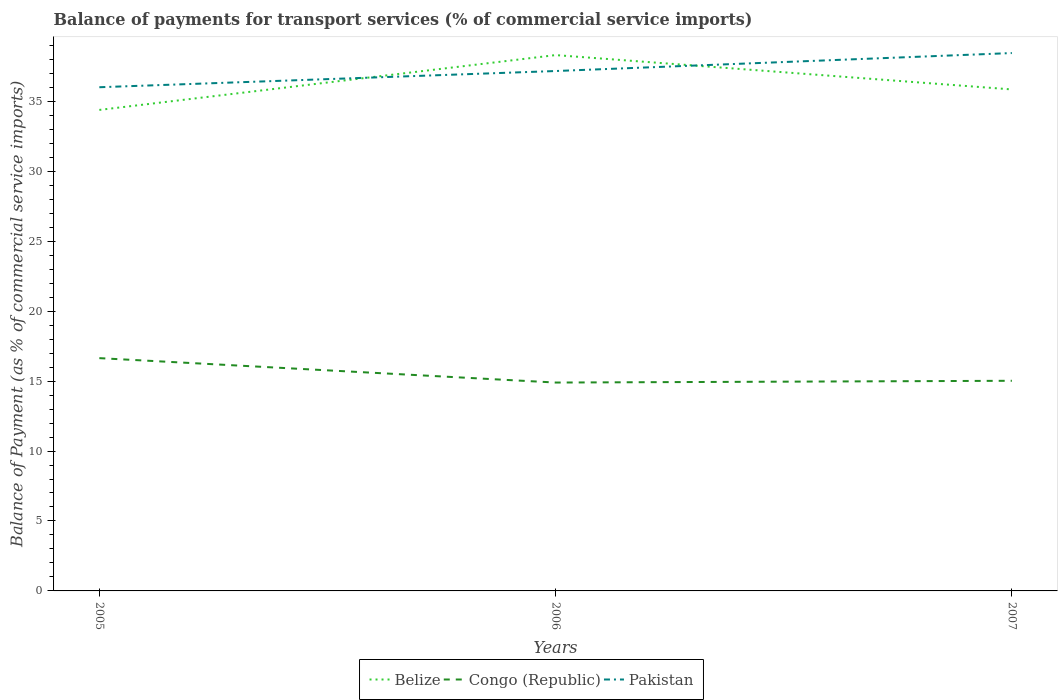Is the number of lines equal to the number of legend labels?
Provide a short and direct response. Yes. Across all years, what is the maximum balance of payments for transport services in Congo (Republic)?
Your answer should be compact. 14.89. In which year was the balance of payments for transport services in Pakistan maximum?
Give a very brief answer. 2005. What is the total balance of payments for transport services in Belize in the graph?
Provide a short and direct response. 2.46. What is the difference between the highest and the second highest balance of payments for transport services in Pakistan?
Your answer should be compact. 2.44. What is the difference between the highest and the lowest balance of payments for transport services in Belize?
Make the answer very short. 1. How many lines are there?
Your answer should be very brief. 3. How many years are there in the graph?
Offer a terse response. 3. What is the difference between two consecutive major ticks on the Y-axis?
Provide a succinct answer. 5. Are the values on the major ticks of Y-axis written in scientific E-notation?
Your answer should be compact. No. Does the graph contain any zero values?
Provide a succinct answer. No. Where does the legend appear in the graph?
Offer a terse response. Bottom center. What is the title of the graph?
Give a very brief answer. Balance of payments for transport services (% of commercial service imports). What is the label or title of the Y-axis?
Make the answer very short. Balance of Payment (as % of commercial service imports). What is the Balance of Payment (as % of commercial service imports) of Belize in 2005?
Ensure brevity in your answer.  34.38. What is the Balance of Payment (as % of commercial service imports) of Congo (Republic) in 2005?
Your answer should be very brief. 16.64. What is the Balance of Payment (as % of commercial service imports) in Pakistan in 2005?
Your answer should be compact. 36. What is the Balance of Payment (as % of commercial service imports) of Belize in 2006?
Keep it short and to the point. 38.3. What is the Balance of Payment (as % of commercial service imports) of Congo (Republic) in 2006?
Provide a short and direct response. 14.89. What is the Balance of Payment (as % of commercial service imports) of Pakistan in 2006?
Offer a terse response. 37.16. What is the Balance of Payment (as % of commercial service imports) of Belize in 2007?
Make the answer very short. 35.85. What is the Balance of Payment (as % of commercial service imports) of Congo (Republic) in 2007?
Offer a very short reply. 15.02. What is the Balance of Payment (as % of commercial service imports) of Pakistan in 2007?
Make the answer very short. 38.45. Across all years, what is the maximum Balance of Payment (as % of commercial service imports) of Belize?
Your answer should be very brief. 38.3. Across all years, what is the maximum Balance of Payment (as % of commercial service imports) in Congo (Republic)?
Make the answer very short. 16.64. Across all years, what is the maximum Balance of Payment (as % of commercial service imports) of Pakistan?
Your answer should be very brief. 38.45. Across all years, what is the minimum Balance of Payment (as % of commercial service imports) of Belize?
Your response must be concise. 34.38. Across all years, what is the minimum Balance of Payment (as % of commercial service imports) in Congo (Republic)?
Give a very brief answer. 14.89. Across all years, what is the minimum Balance of Payment (as % of commercial service imports) in Pakistan?
Keep it short and to the point. 36. What is the total Balance of Payment (as % of commercial service imports) in Belize in the graph?
Provide a short and direct response. 108.53. What is the total Balance of Payment (as % of commercial service imports) in Congo (Republic) in the graph?
Give a very brief answer. 46.56. What is the total Balance of Payment (as % of commercial service imports) in Pakistan in the graph?
Ensure brevity in your answer.  111.62. What is the difference between the Balance of Payment (as % of commercial service imports) in Belize in 2005 and that in 2006?
Offer a terse response. -3.92. What is the difference between the Balance of Payment (as % of commercial service imports) in Congo (Republic) in 2005 and that in 2006?
Give a very brief answer. 1.74. What is the difference between the Balance of Payment (as % of commercial service imports) in Pakistan in 2005 and that in 2006?
Ensure brevity in your answer.  -1.16. What is the difference between the Balance of Payment (as % of commercial service imports) of Belize in 2005 and that in 2007?
Give a very brief answer. -1.46. What is the difference between the Balance of Payment (as % of commercial service imports) in Congo (Republic) in 2005 and that in 2007?
Offer a terse response. 1.62. What is the difference between the Balance of Payment (as % of commercial service imports) in Pakistan in 2005 and that in 2007?
Give a very brief answer. -2.44. What is the difference between the Balance of Payment (as % of commercial service imports) of Belize in 2006 and that in 2007?
Ensure brevity in your answer.  2.46. What is the difference between the Balance of Payment (as % of commercial service imports) in Congo (Republic) in 2006 and that in 2007?
Your response must be concise. -0.13. What is the difference between the Balance of Payment (as % of commercial service imports) of Pakistan in 2006 and that in 2007?
Offer a terse response. -1.28. What is the difference between the Balance of Payment (as % of commercial service imports) of Belize in 2005 and the Balance of Payment (as % of commercial service imports) of Congo (Republic) in 2006?
Give a very brief answer. 19.49. What is the difference between the Balance of Payment (as % of commercial service imports) of Belize in 2005 and the Balance of Payment (as % of commercial service imports) of Pakistan in 2006?
Offer a very short reply. -2.78. What is the difference between the Balance of Payment (as % of commercial service imports) in Congo (Republic) in 2005 and the Balance of Payment (as % of commercial service imports) in Pakistan in 2006?
Your response must be concise. -20.52. What is the difference between the Balance of Payment (as % of commercial service imports) of Belize in 2005 and the Balance of Payment (as % of commercial service imports) of Congo (Republic) in 2007?
Your answer should be very brief. 19.36. What is the difference between the Balance of Payment (as % of commercial service imports) of Belize in 2005 and the Balance of Payment (as % of commercial service imports) of Pakistan in 2007?
Keep it short and to the point. -4.07. What is the difference between the Balance of Payment (as % of commercial service imports) in Congo (Republic) in 2005 and the Balance of Payment (as % of commercial service imports) in Pakistan in 2007?
Provide a succinct answer. -21.81. What is the difference between the Balance of Payment (as % of commercial service imports) in Belize in 2006 and the Balance of Payment (as % of commercial service imports) in Congo (Republic) in 2007?
Provide a succinct answer. 23.28. What is the difference between the Balance of Payment (as % of commercial service imports) of Belize in 2006 and the Balance of Payment (as % of commercial service imports) of Pakistan in 2007?
Make the answer very short. -0.15. What is the difference between the Balance of Payment (as % of commercial service imports) of Congo (Republic) in 2006 and the Balance of Payment (as % of commercial service imports) of Pakistan in 2007?
Provide a short and direct response. -23.55. What is the average Balance of Payment (as % of commercial service imports) of Belize per year?
Give a very brief answer. 36.18. What is the average Balance of Payment (as % of commercial service imports) of Congo (Republic) per year?
Your answer should be very brief. 15.52. What is the average Balance of Payment (as % of commercial service imports) in Pakistan per year?
Ensure brevity in your answer.  37.2. In the year 2005, what is the difference between the Balance of Payment (as % of commercial service imports) in Belize and Balance of Payment (as % of commercial service imports) in Congo (Republic)?
Provide a short and direct response. 17.74. In the year 2005, what is the difference between the Balance of Payment (as % of commercial service imports) in Belize and Balance of Payment (as % of commercial service imports) in Pakistan?
Keep it short and to the point. -1.62. In the year 2005, what is the difference between the Balance of Payment (as % of commercial service imports) of Congo (Republic) and Balance of Payment (as % of commercial service imports) of Pakistan?
Provide a short and direct response. -19.36. In the year 2006, what is the difference between the Balance of Payment (as % of commercial service imports) in Belize and Balance of Payment (as % of commercial service imports) in Congo (Republic)?
Ensure brevity in your answer.  23.41. In the year 2006, what is the difference between the Balance of Payment (as % of commercial service imports) of Belize and Balance of Payment (as % of commercial service imports) of Pakistan?
Your response must be concise. 1.14. In the year 2006, what is the difference between the Balance of Payment (as % of commercial service imports) of Congo (Republic) and Balance of Payment (as % of commercial service imports) of Pakistan?
Make the answer very short. -22.27. In the year 2007, what is the difference between the Balance of Payment (as % of commercial service imports) in Belize and Balance of Payment (as % of commercial service imports) in Congo (Republic)?
Keep it short and to the point. 20.83. In the year 2007, what is the difference between the Balance of Payment (as % of commercial service imports) of Belize and Balance of Payment (as % of commercial service imports) of Pakistan?
Offer a very short reply. -2.6. In the year 2007, what is the difference between the Balance of Payment (as % of commercial service imports) in Congo (Republic) and Balance of Payment (as % of commercial service imports) in Pakistan?
Provide a succinct answer. -23.43. What is the ratio of the Balance of Payment (as % of commercial service imports) of Belize in 2005 to that in 2006?
Offer a terse response. 0.9. What is the ratio of the Balance of Payment (as % of commercial service imports) of Congo (Republic) in 2005 to that in 2006?
Your answer should be very brief. 1.12. What is the ratio of the Balance of Payment (as % of commercial service imports) of Pakistan in 2005 to that in 2006?
Ensure brevity in your answer.  0.97. What is the ratio of the Balance of Payment (as % of commercial service imports) of Belize in 2005 to that in 2007?
Your answer should be very brief. 0.96. What is the ratio of the Balance of Payment (as % of commercial service imports) in Congo (Republic) in 2005 to that in 2007?
Your response must be concise. 1.11. What is the ratio of the Balance of Payment (as % of commercial service imports) of Pakistan in 2005 to that in 2007?
Give a very brief answer. 0.94. What is the ratio of the Balance of Payment (as % of commercial service imports) of Belize in 2006 to that in 2007?
Give a very brief answer. 1.07. What is the ratio of the Balance of Payment (as % of commercial service imports) in Congo (Republic) in 2006 to that in 2007?
Your response must be concise. 0.99. What is the ratio of the Balance of Payment (as % of commercial service imports) of Pakistan in 2006 to that in 2007?
Provide a short and direct response. 0.97. What is the difference between the highest and the second highest Balance of Payment (as % of commercial service imports) in Belize?
Give a very brief answer. 2.46. What is the difference between the highest and the second highest Balance of Payment (as % of commercial service imports) of Congo (Republic)?
Ensure brevity in your answer.  1.62. What is the difference between the highest and the second highest Balance of Payment (as % of commercial service imports) of Pakistan?
Provide a short and direct response. 1.28. What is the difference between the highest and the lowest Balance of Payment (as % of commercial service imports) of Belize?
Your response must be concise. 3.92. What is the difference between the highest and the lowest Balance of Payment (as % of commercial service imports) in Congo (Republic)?
Give a very brief answer. 1.74. What is the difference between the highest and the lowest Balance of Payment (as % of commercial service imports) in Pakistan?
Offer a very short reply. 2.44. 